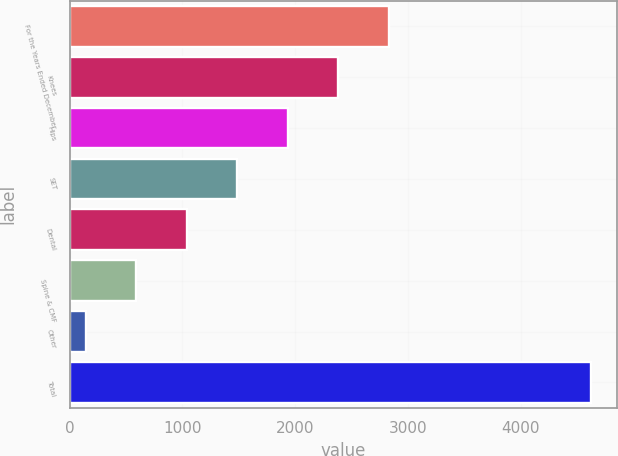Convert chart. <chart><loc_0><loc_0><loc_500><loc_500><bar_chart><fcel>For the Years Ended December<fcel>Knees<fcel>Hips<fcel>SET<fcel>Dental<fcel>Spine & CMF<fcel>Other<fcel>Total<nl><fcel>2830.8<fcel>2382.65<fcel>1934.5<fcel>1486.35<fcel>1038.2<fcel>590.05<fcel>141.9<fcel>4623.4<nl></chart> 